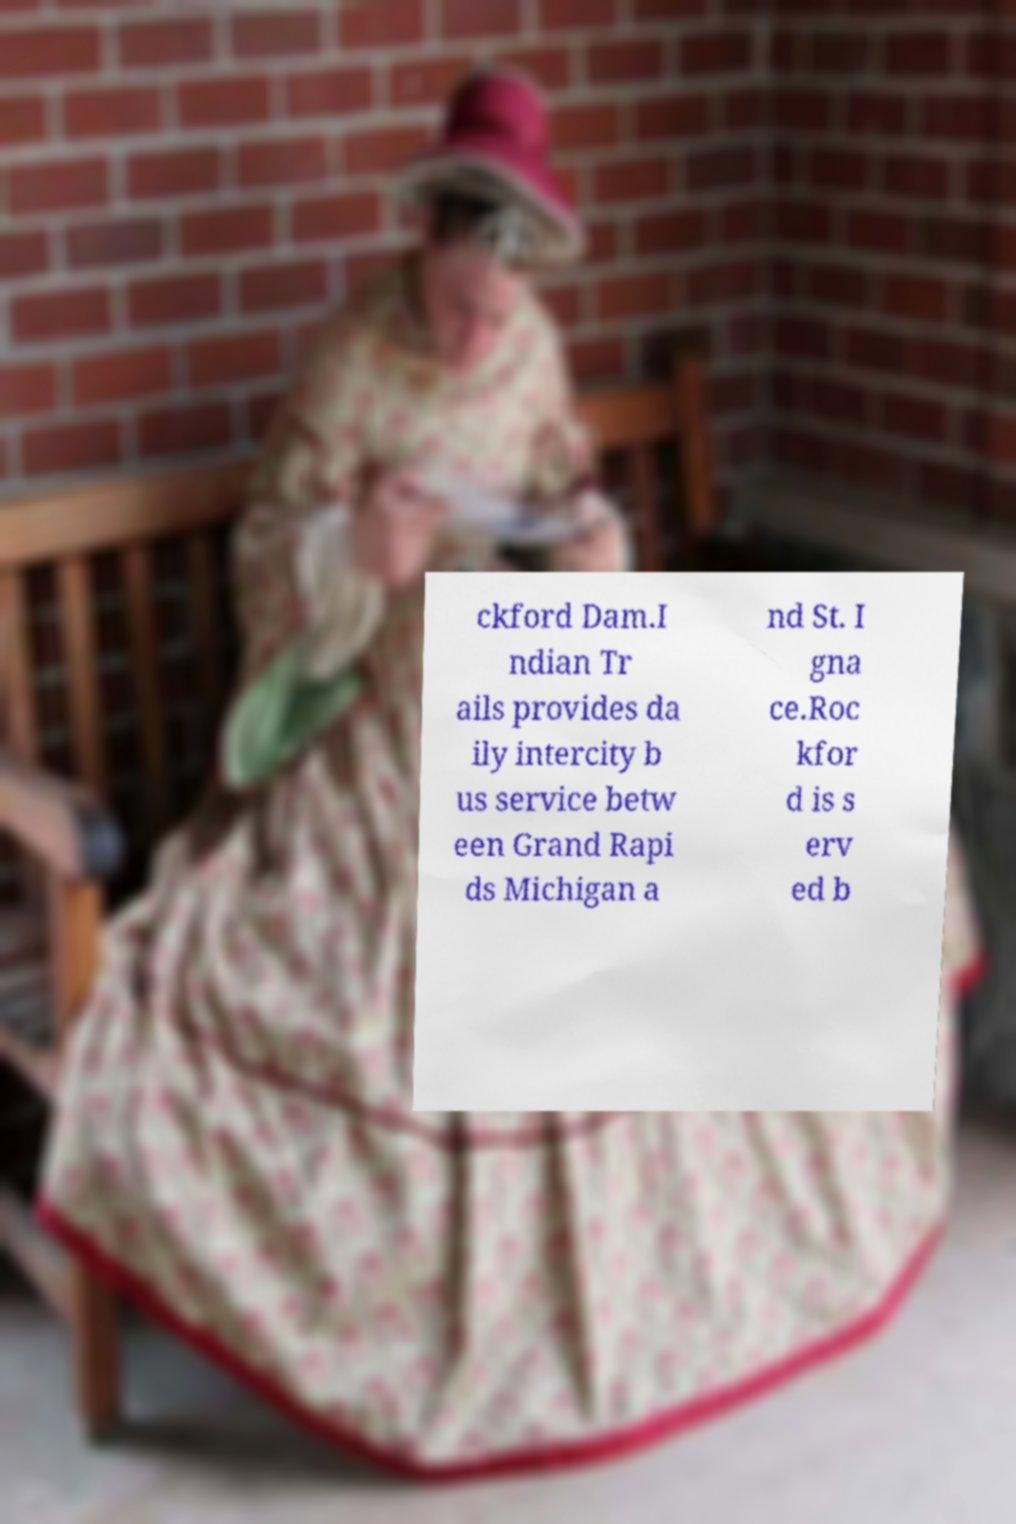Could you extract and type out the text from this image? ckford Dam.I ndian Tr ails provides da ily intercity b us service betw een Grand Rapi ds Michigan a nd St. I gna ce.Roc kfor d is s erv ed b 